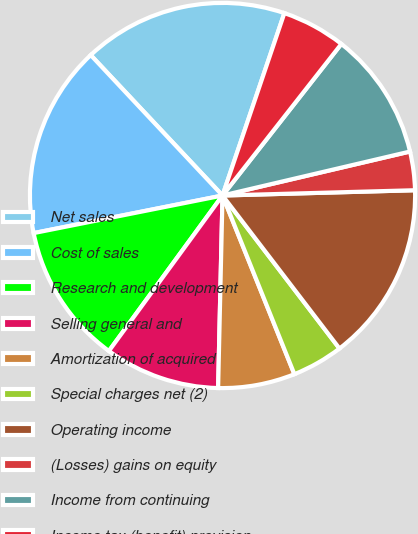<chart> <loc_0><loc_0><loc_500><loc_500><pie_chart><fcel>Net sales<fcel>Cost of sales<fcel>Research and development<fcel>Selling general and<fcel>Amortization of acquired<fcel>Special charges net (2)<fcel>Operating income<fcel>(Losses) gains on equity<fcel>Income from continuing<fcel>Income tax (benefit) provision<nl><fcel>17.2%<fcel>16.13%<fcel>11.83%<fcel>9.68%<fcel>6.45%<fcel>4.3%<fcel>15.05%<fcel>3.23%<fcel>10.75%<fcel>5.38%<nl></chart> 